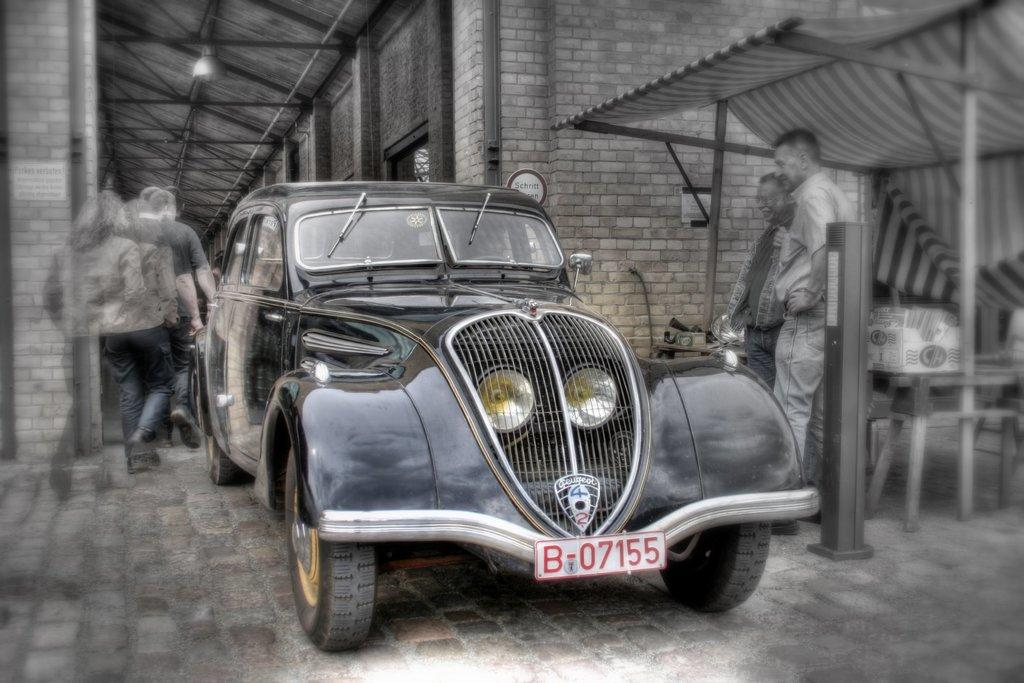What structure is visible in the image? There is a building in the image. What are the people in the image doing? There are people walking in the image, and some people are standing near the car. What vehicle is present in the image? There is a car in the image. How are the people near the car behaving? The people near the car are looking at the car. Can you hear the zebra coughing in the image? There is no zebra or coughing sound present in the image. How many people are gripping the car in the image? There is no indication in the image that anyone is gripping the car. 